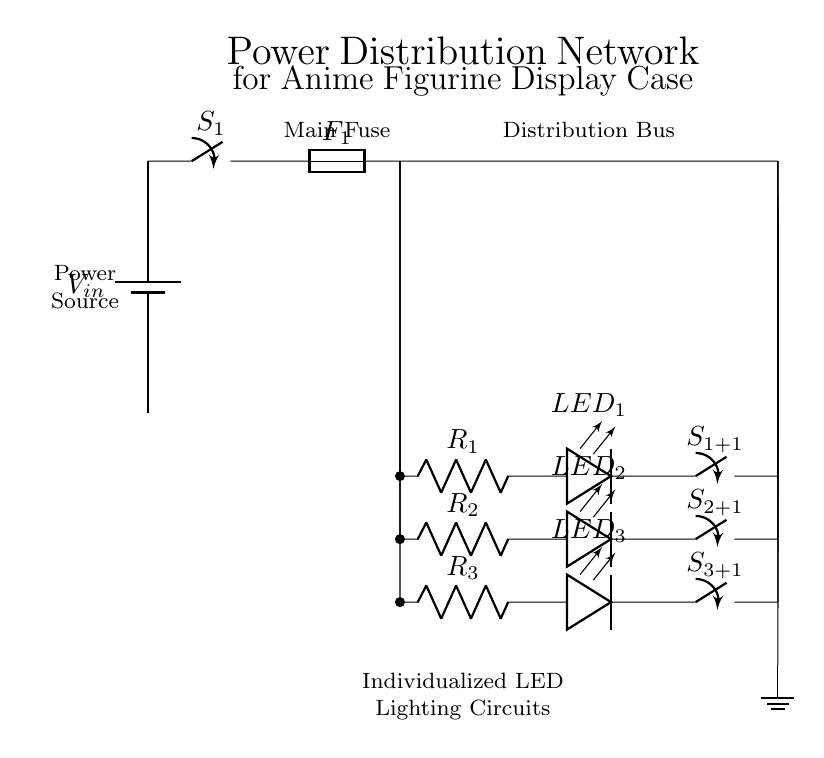What is the main component supplying power? The main component supplying power is a battery. It is represented at the beginning of the circuit and indicated by the symbol for a battery.
Answer: Battery How many individual LED circuits are there? There are three individual LED circuits. This is identified by counting the instances of the LED circuits connected to the distribution bus.
Answer: Three What is the function of the fuse? The function of the fuse is to protect the circuit from overcurrent situations by breaking the circuit when excessive current flows through. It is located immediately after the main switch.
Answer: Protection What is the total number of switches in this circuit? The total number of switches in this circuit is four: one main switch and three individual switches for each LED circuit. This can be counted from the circuit diagram, where each switch is clearly labeled.
Answer: Four What happens when any switch is in the 'off' position? When any switch is in the 'off' position, the corresponding LED circuit will not have current flowing through it, thus it will not light up. This can be inferred from the series configuration of the switches and LEDs.
Answer: LED off Which element connects to the ground? The element connecting to the ground is the distribution bus. It is shown as a line that leads towards the ground symbol at the bottom of the circuit diagram.
Answer: Distribution bus 